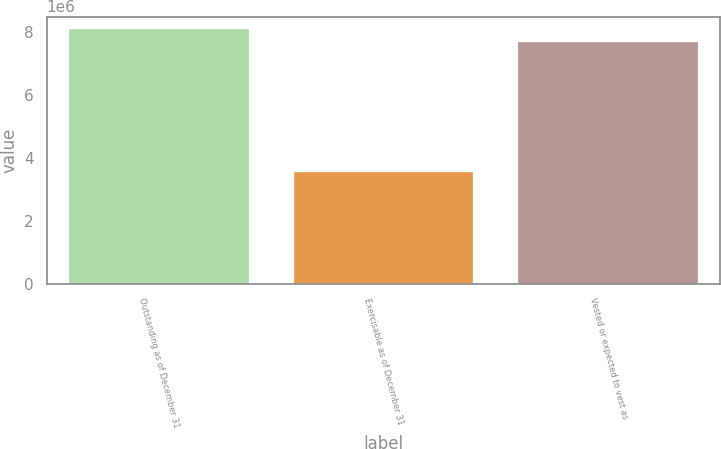Convert chart. <chart><loc_0><loc_0><loc_500><loc_500><bar_chart><fcel>Outstanding as of December 31<fcel>Exercisable as of December 31<fcel>Vested or expected to vest as<nl><fcel>8.08744e+06<fcel>3.54971e+06<fcel>7.67432e+06<nl></chart> 